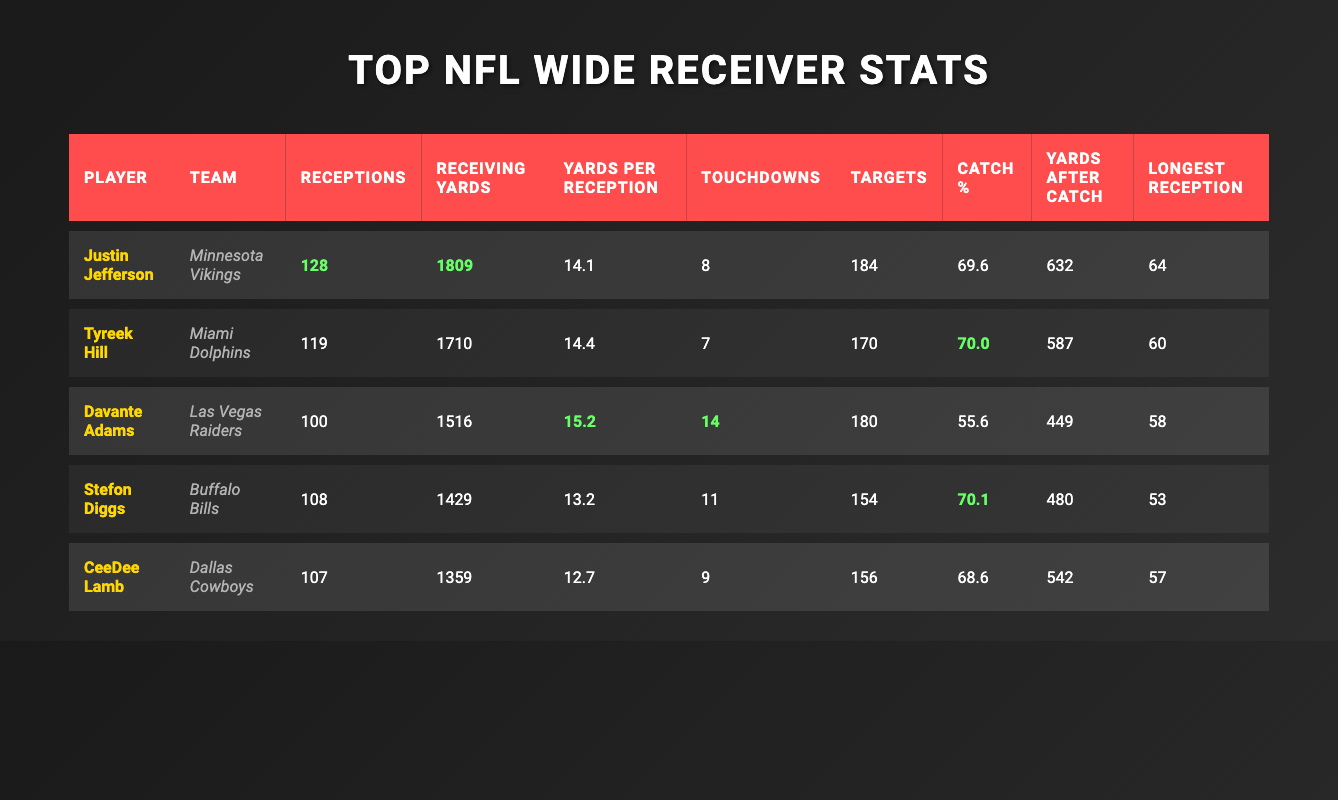What is the highest number of receptions by a wide receiver in this table? Justin Jefferson has the highest number of receptions at 128. This is clearly visible in the "Receptions" column of the table, where he outnumbers other players.
Answer: 128 Which player has the most touchdowns? Davante Adams has the most touchdowns at 14, as shown in the "Touchdowns" column. Comparing the numbers, he exceeds other players listed.
Answer: 14 What is the average receiving yards of the players listed in the table? To find the average, sum all receiving yards: 1809 + 1710 + 1516 + 1429 + 1359 = 6913. There are 5 players, so divide the total by 5: 6913/5 = 1382.6.
Answer: 1382.6 Is Tyreek Hill’s catch percentage greater than 70%? Tyreek Hill's catch percentage is 70.0%, which is equal to 70%, not greater. This can be checked directly in the "Catch %" column.
Answer: No Which two players have a similar number of receptions? CeeDee Lamb and Stefon Diggs both have 107 and 108 receptions respectively. Looking at the "Receptions" column, their numbers are closely related, indicating they performed similarly in terms of catching passes.
Answer: CeeDee Lamb and Stefon Diggs What is the difference in receiving yards between Justin Jefferson and Stefon Diggs? Justin Jefferson has 1809 receiving yards, while Stefon Diggs has 1429. The difference is calculated as: 1809 - 1429 = 380, making Jefferson's receiving yards significantly higher.
Answer: 380 Who had the longest reception? Justin Jefferson recorded the longest reception at 64 yards as indicated in the "Longest Reception" column. This is the top value in that column.
Answer: 64 What percentage of his targets did Davante Adams catch? Davante Adams caught 100 receptions out of 180 targets. To find the catch percentage, calculate (100/180) * 100 = 55.6%. This is identified as his catch percentage in the "Catch %" column.
Answer: 55.6 Which player had the highest yards after catch? Justin Jefferson had the highest yards after catch at 632, which can be seen in the "Yards After Catch" column of the table. This is greater than any other player listed.
Answer: 632 